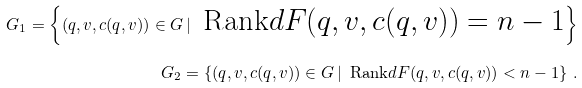<formula> <loc_0><loc_0><loc_500><loc_500>G _ { 1 } = \left \{ ( q , v , c ( q , v ) ) \in G \, | \, \text { Rank$dF(q,v,c(q,v))=n-1$} \right \} \\ G _ { 2 } = \left \{ ( q , v , c ( q , v ) ) \in G \, | \, \text { Rank$dF(q,v,c(q,v))<n-1$} \right \} \, .</formula> 